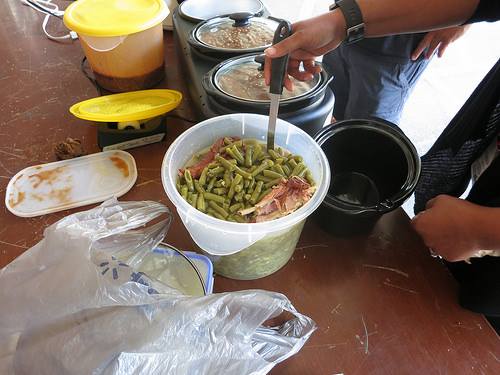<image>
Is the box under the food? Yes. The box is positioned underneath the food, with the food above it in the vertical space. Is the food in the pot? Yes. The food is contained within or inside the pot, showing a containment relationship. Is the spoon in the green bean? Yes. The spoon is contained within or inside the green bean, showing a containment relationship. 